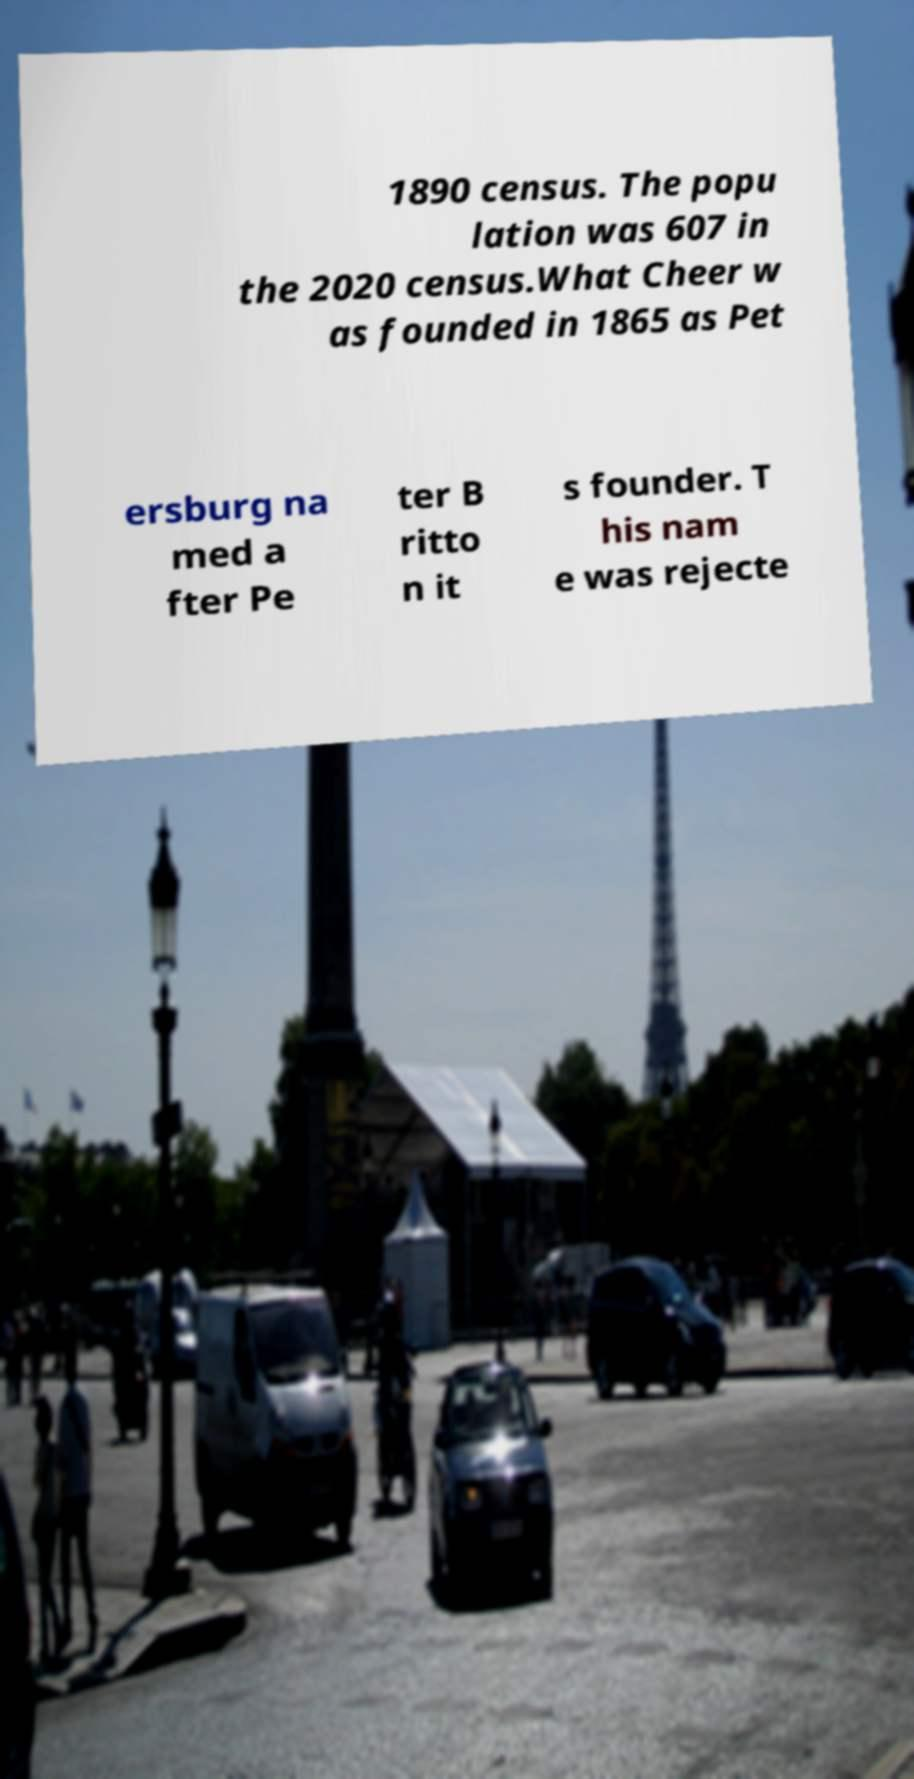Can you accurately transcribe the text from the provided image for me? 1890 census. The popu lation was 607 in the 2020 census.What Cheer w as founded in 1865 as Pet ersburg na med a fter Pe ter B ritto n it s founder. T his nam e was rejecte 